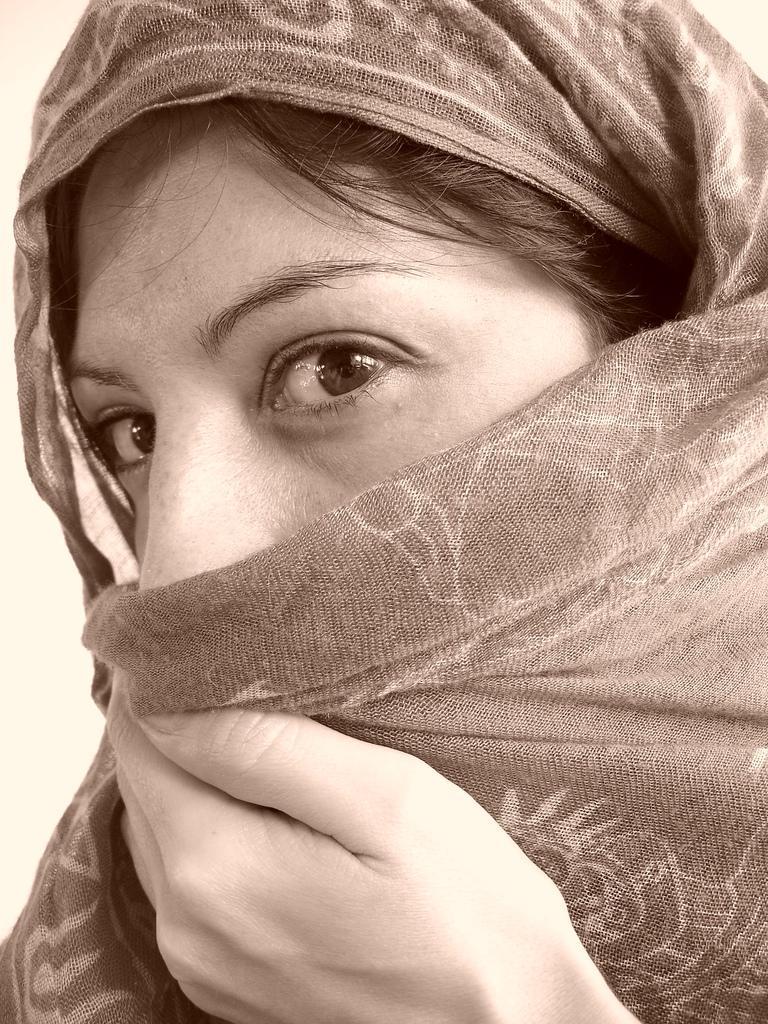Can you describe this image briefly? In this image, I can see the woman's face, which is covered with a cloth. I can see the design on the cloth. 